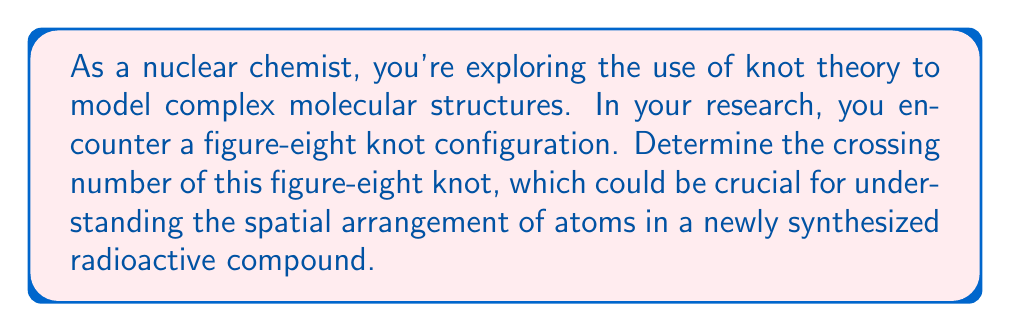Could you help me with this problem? To determine the crossing number of a figure-eight knot, we need to follow these steps:

1. Understand the definition: The crossing number of a knot is the minimum number of crossings that occur in any projection of the knot onto a plane.

2. Visualize the figure-eight knot:
   [asy]
   import geometry;
   
   path p = (0,0)..(1,1)..(2,0)..(1,-1)..cycle;
   path q = (0.5,0.5)..(1.5,-0.5)..(1.5,0.5)..(0.5,-0.5)..cycle;
   
   draw(p, linewidth(1));
   draw(q, linewidth(1));
   
   dot((0.75,0.25));
   dot((1.25,0.25));
   dot((0.75,-0.25));
   dot((1.25,-0.25));
   [/asy]

3. Count the crossings: In the standard projection of a figure-eight knot, we can clearly see 4 crossings.

4. Prove minimality: To prove that 4 is indeed the minimum number of crossings, we need to use some advanced knot theory concepts:

   a) The figure-eight knot is known to be a prime knot, meaning it cannot be decomposed into simpler knots.
   
   b) It has a non-trivial Jones polynomial: $V(t) = t^2 - t + 1 - t^{-1} + t^{-2}$
   
   c) The span of this polynomial (difference between highest and lowest exponents) is 4.
   
   d) For alternating knots (which the figure-eight knot is), the span of the Jones polynomial equals the crossing number.

5. Conclusion: Based on these properties, we can conclude that the crossing number of the figure-eight knot is indeed 4, and it's impossible to represent this knot with fewer crossings.

This crossing number could be significant in understanding the complexity and spatial arrangement of atoms in your radioactive compound, potentially influencing its chemical properties and decay patterns.
Answer: 4 